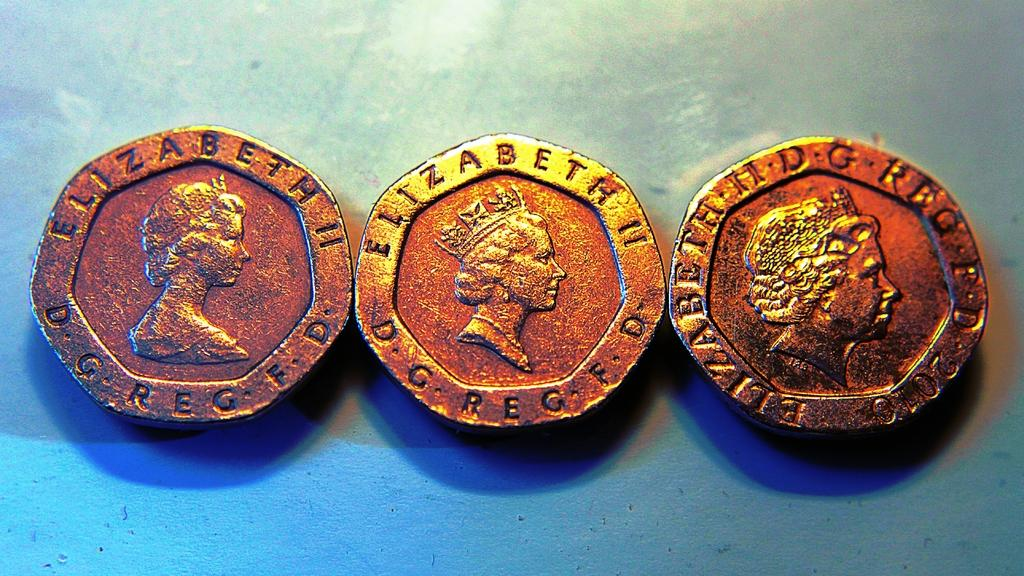<image>
Present a compact description of the photo's key features. Three differently styled coins with Elizabeth II on the front are side by side for comparison. 